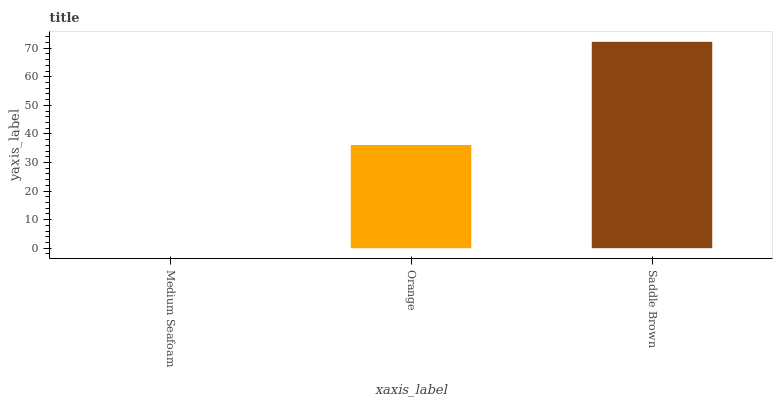Is Medium Seafoam the minimum?
Answer yes or no. Yes. Is Saddle Brown the maximum?
Answer yes or no. Yes. Is Orange the minimum?
Answer yes or no. No. Is Orange the maximum?
Answer yes or no. No. Is Orange greater than Medium Seafoam?
Answer yes or no. Yes. Is Medium Seafoam less than Orange?
Answer yes or no. Yes. Is Medium Seafoam greater than Orange?
Answer yes or no. No. Is Orange less than Medium Seafoam?
Answer yes or no. No. Is Orange the high median?
Answer yes or no. Yes. Is Orange the low median?
Answer yes or no. Yes. Is Saddle Brown the high median?
Answer yes or no. No. Is Medium Seafoam the low median?
Answer yes or no. No. 